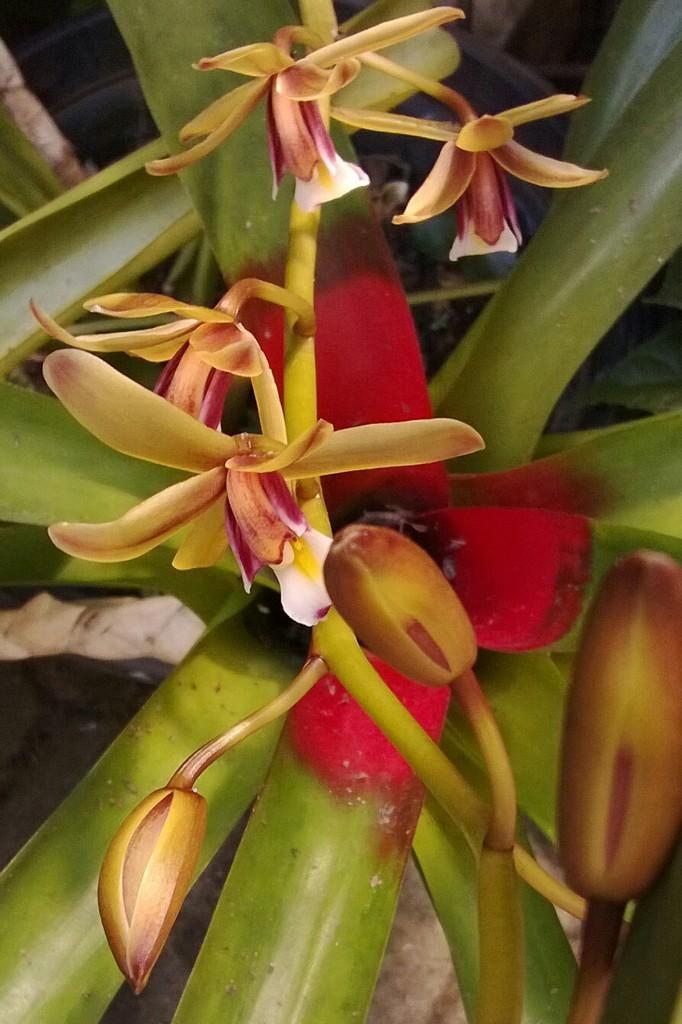What is present in the image? There is a plant in the image. What can be observed about the plant? The plant has flowers. What type of milk is being used to water the plant in the image? There is no milk present in the image, and the plant is not being watered. 